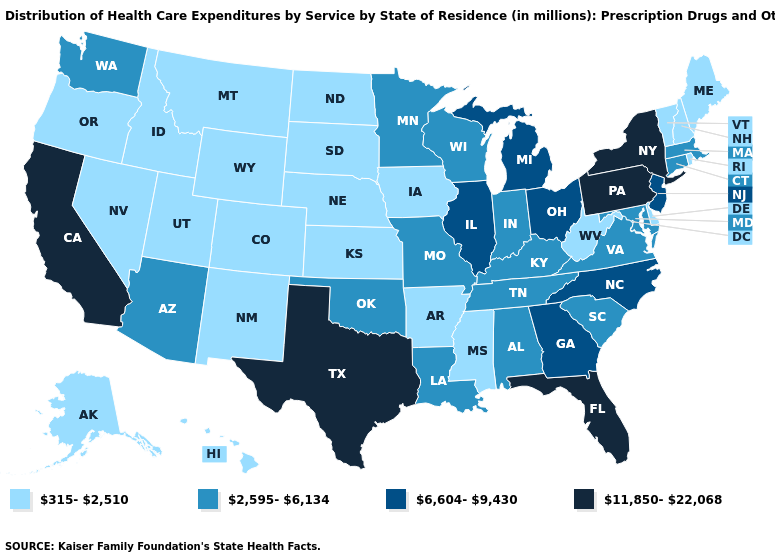What is the value of Florida?
Short answer required. 11,850-22,068. What is the lowest value in the USA?
Concise answer only. 315-2,510. Among the states that border Alabama , which have the lowest value?
Answer briefly. Mississippi. Does the map have missing data?
Give a very brief answer. No. What is the value of Oregon?
Write a very short answer. 315-2,510. Name the states that have a value in the range 11,850-22,068?
Give a very brief answer. California, Florida, New York, Pennsylvania, Texas. Name the states that have a value in the range 315-2,510?
Quick response, please. Alaska, Arkansas, Colorado, Delaware, Hawaii, Idaho, Iowa, Kansas, Maine, Mississippi, Montana, Nebraska, Nevada, New Hampshire, New Mexico, North Dakota, Oregon, Rhode Island, South Dakota, Utah, Vermont, West Virginia, Wyoming. What is the lowest value in the West?
Quick response, please. 315-2,510. Does Wyoming have a lower value than Minnesota?
Keep it brief. Yes. Which states hav the highest value in the Northeast?
Give a very brief answer. New York, Pennsylvania. What is the value of North Dakota?
Quick response, please. 315-2,510. What is the value of Kansas?
Be succinct. 315-2,510. Among the states that border Massachusetts , which have the lowest value?
Concise answer only. New Hampshire, Rhode Island, Vermont. Does Vermont have the lowest value in the Northeast?
Concise answer only. Yes. What is the highest value in the USA?
Give a very brief answer. 11,850-22,068. 